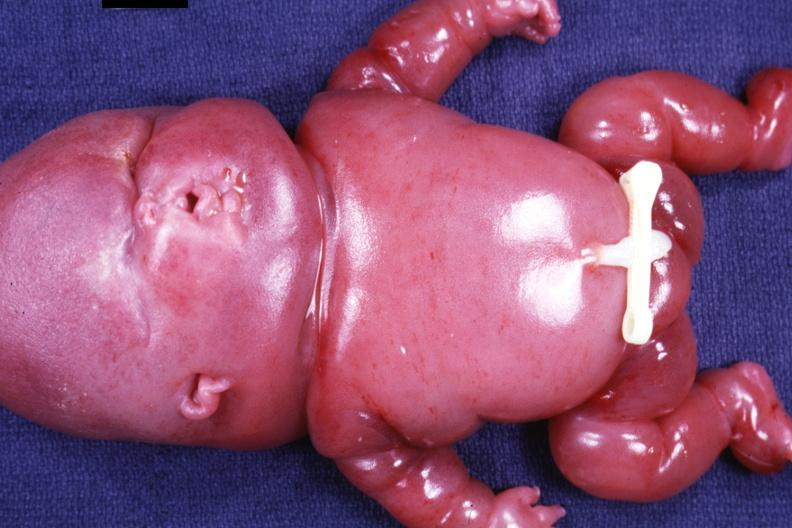does granulomata slide show anterior view of whole body?
Answer the question using a single word or phrase. No 